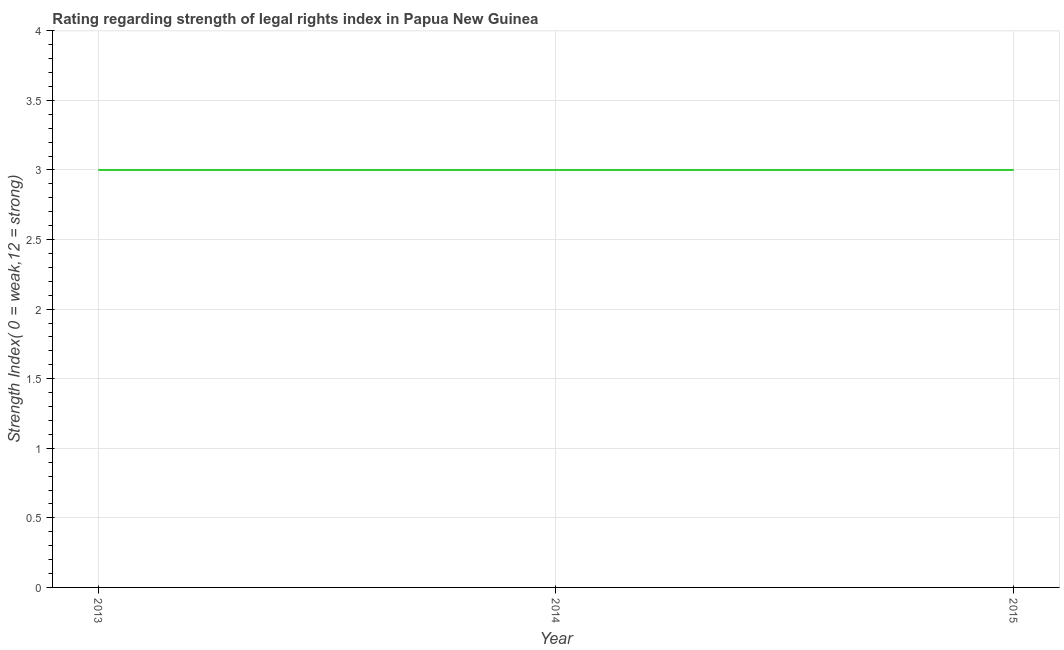What is the strength of legal rights index in 2014?
Your answer should be very brief. 3. Across all years, what is the maximum strength of legal rights index?
Make the answer very short. 3. Across all years, what is the minimum strength of legal rights index?
Make the answer very short. 3. In which year was the strength of legal rights index maximum?
Your answer should be very brief. 2013. In which year was the strength of legal rights index minimum?
Your response must be concise. 2013. What is the sum of the strength of legal rights index?
Keep it short and to the point. 9. What is the difference between the strength of legal rights index in 2014 and 2015?
Provide a short and direct response. 0. What is the average strength of legal rights index per year?
Offer a terse response. 3. Do a majority of the years between 2013 and 2015 (inclusive) have strength of legal rights index greater than 3.2 ?
Offer a very short reply. No. Is the difference between the strength of legal rights index in 2013 and 2014 greater than the difference between any two years?
Your answer should be very brief. Yes. What is the difference between the highest and the second highest strength of legal rights index?
Ensure brevity in your answer.  0. In how many years, is the strength of legal rights index greater than the average strength of legal rights index taken over all years?
Provide a short and direct response. 0. What is the difference between two consecutive major ticks on the Y-axis?
Your answer should be very brief. 0.5. Does the graph contain grids?
Your answer should be compact. Yes. What is the title of the graph?
Keep it short and to the point. Rating regarding strength of legal rights index in Papua New Guinea. What is the label or title of the X-axis?
Offer a terse response. Year. What is the label or title of the Y-axis?
Keep it short and to the point. Strength Index( 0 = weak,12 = strong). What is the Strength Index( 0 = weak,12 = strong) of 2013?
Your answer should be very brief. 3. What is the Strength Index( 0 = weak,12 = strong) in 2015?
Keep it short and to the point. 3. What is the difference between the Strength Index( 0 = weak,12 = strong) in 2013 and 2014?
Provide a short and direct response. 0. What is the difference between the Strength Index( 0 = weak,12 = strong) in 2013 and 2015?
Offer a terse response. 0. What is the difference between the Strength Index( 0 = weak,12 = strong) in 2014 and 2015?
Your response must be concise. 0. What is the ratio of the Strength Index( 0 = weak,12 = strong) in 2013 to that in 2014?
Ensure brevity in your answer.  1. What is the ratio of the Strength Index( 0 = weak,12 = strong) in 2013 to that in 2015?
Give a very brief answer. 1. What is the ratio of the Strength Index( 0 = weak,12 = strong) in 2014 to that in 2015?
Provide a short and direct response. 1. 